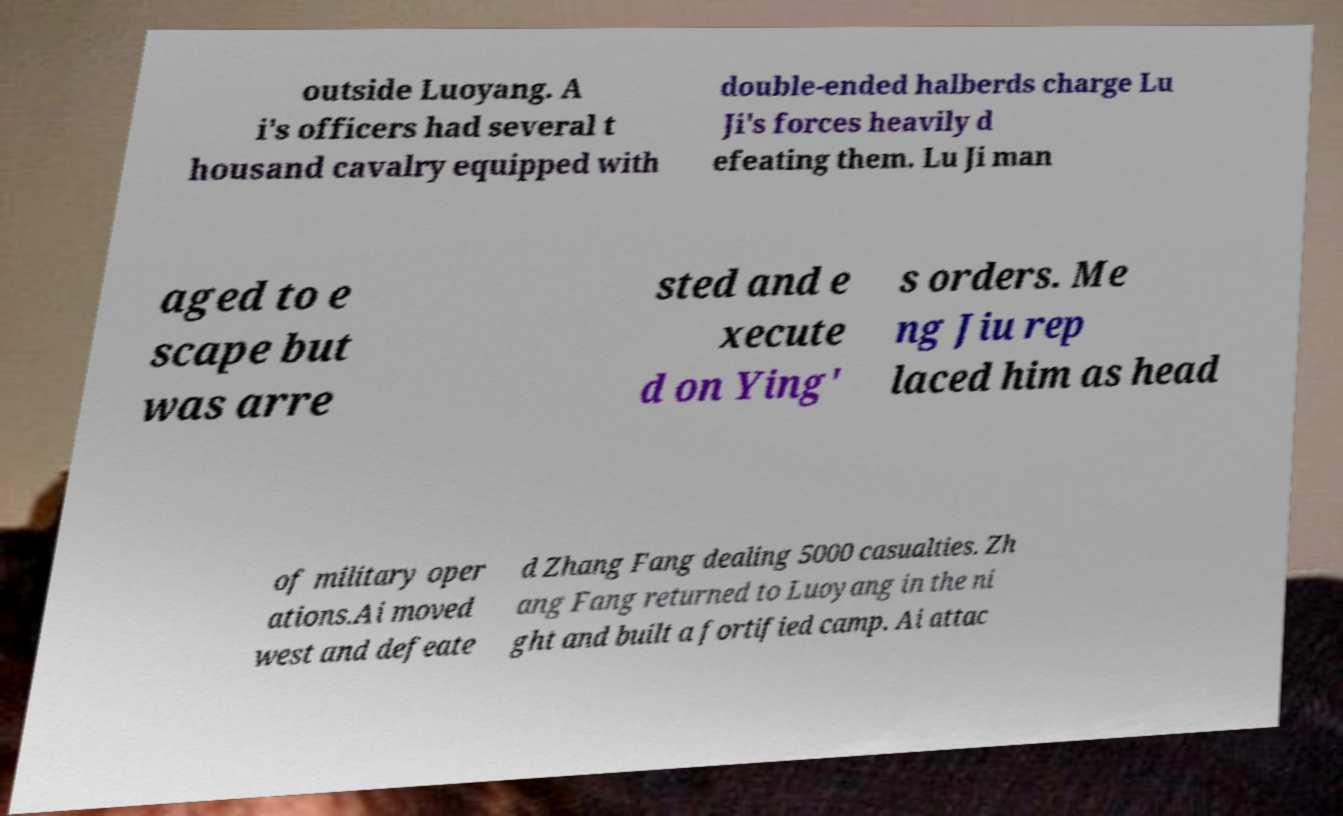Can you accurately transcribe the text from the provided image for me? outside Luoyang. A i's officers had several t housand cavalry equipped with double-ended halberds charge Lu Ji's forces heavily d efeating them. Lu Ji man aged to e scape but was arre sted and e xecute d on Ying' s orders. Me ng Jiu rep laced him as head of military oper ations.Ai moved west and defeate d Zhang Fang dealing 5000 casualties. Zh ang Fang returned to Luoyang in the ni ght and built a fortified camp. Ai attac 